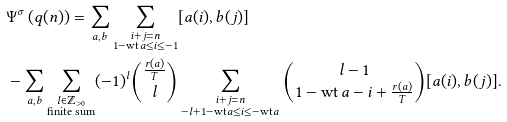Convert formula to latex. <formula><loc_0><loc_0><loc_500><loc_500>& \Psi ^ { \sigma } \left ( q ( n ) \right ) = \sum _ { \substack { a , b } } \sum _ { \substack { i + j = n \\ 1 - \text {wt} \, a \leq i \leq - 1 } } [ a ( i ) , b ( j ) ] \\ & - \sum _ { \substack { a , b } } \sum _ { \substack { l \in \mathbb { Z } _ { > 0 } \\ \text {finite sum} } } ( - 1 ) ^ { l } \binom { \frac { r ( a ) } { T } } { l } \sum _ { \substack { i + j = n \\ - l + 1 - \text {wt} \, a \leq i \leq - \text {wt} \, a } } \binom { l - 1 } { 1 - \text {wt} \, a - i + \frac { r ( a ) } { T } } [ a ( i ) , b ( j ) ] .</formula> 